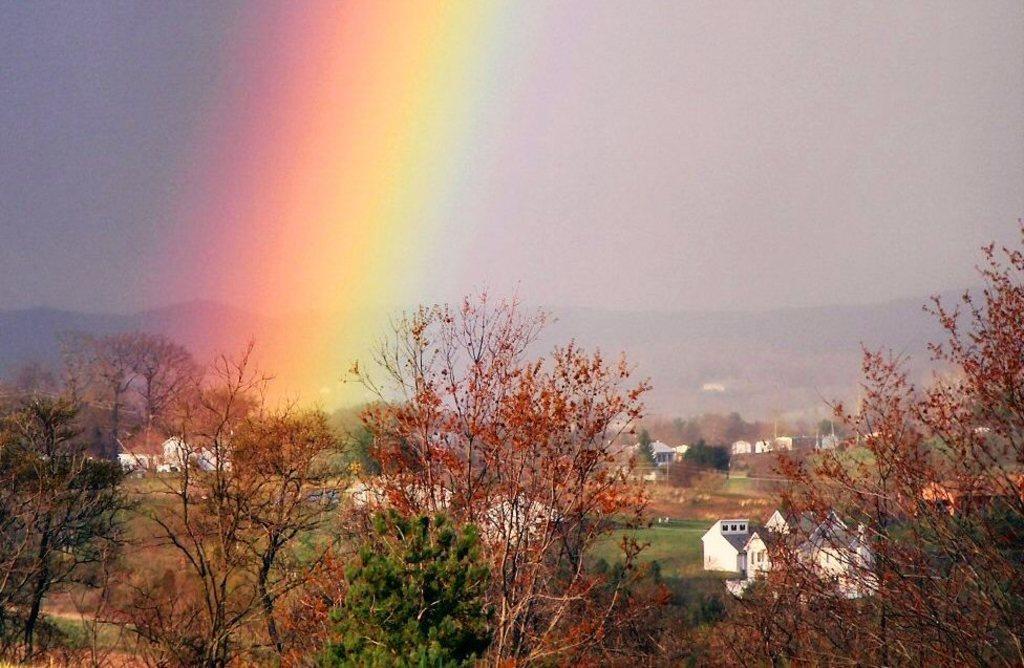In one or two sentences, can you explain what this image depicts? At the bottom of the image, we can see trees, grass and buildings. At the top of the image, we can see the sky and a rainbow. In the background, we can see mountains. 